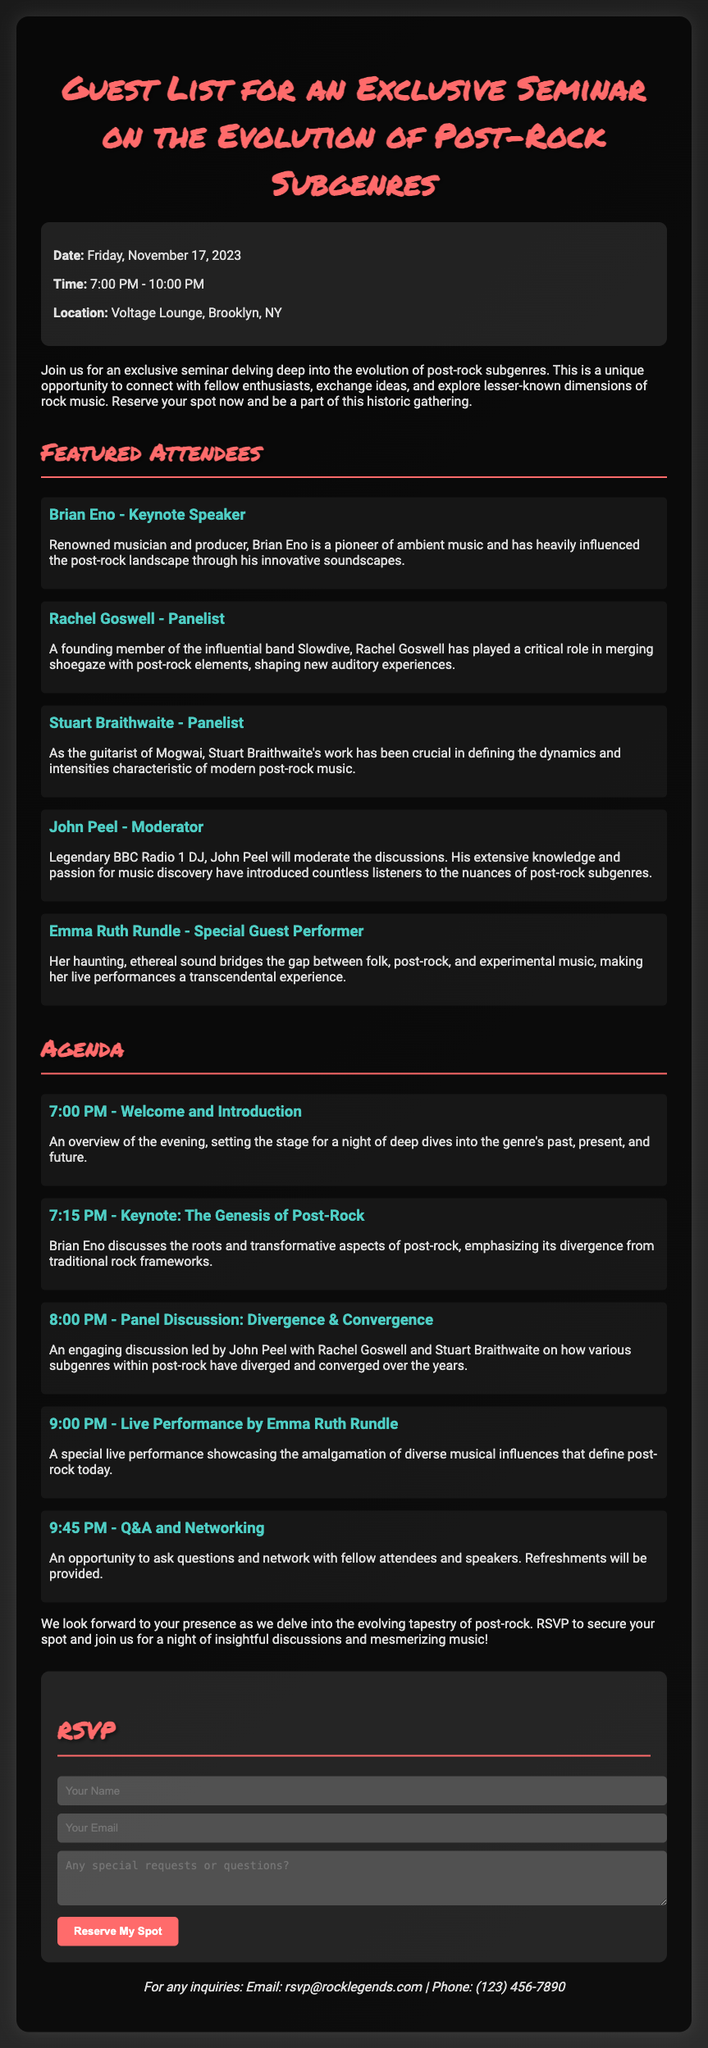What is the date of the seminar? The date is specified in the document and is clearly stated.
Answer: Friday, November 17, 2023 Who is the keynote speaker? The document lists Brian Eno as the keynote speaker for the seminar.
Answer: Brian Eno What time does the seminar start? The starting time is mentioned in the event details at the top of the document.
Answer: 7:00 PM Which location will host the seminar? The document provides the location of the seminar in the details section.
Answer: Voltage Lounge, Brooklyn, NY What will happen at 9:00 PM? The agenda describes the schedule of events and mentions what will occur at that specific time.
Answer: Live Performance by Emma Ruth Rundle What is the purpose of the seminar? The document outlines the purpose of the gathering in the introductory paragraph.
Answer: Explore lesser-known dimensions of rock music How can attendees RSVP? The RSVP section of the document explains how to reserve a spot for the seminar.
Answer: By filling out the form Who will moderate the panel discussion? The document names the moderator of the discussions in the featured attendees section.
Answer: John Peel What type of music will Emma Ruth Rundle perform? The document indicates the genres she bridges in her performance description.
Answer: Post-rock and experimental music 